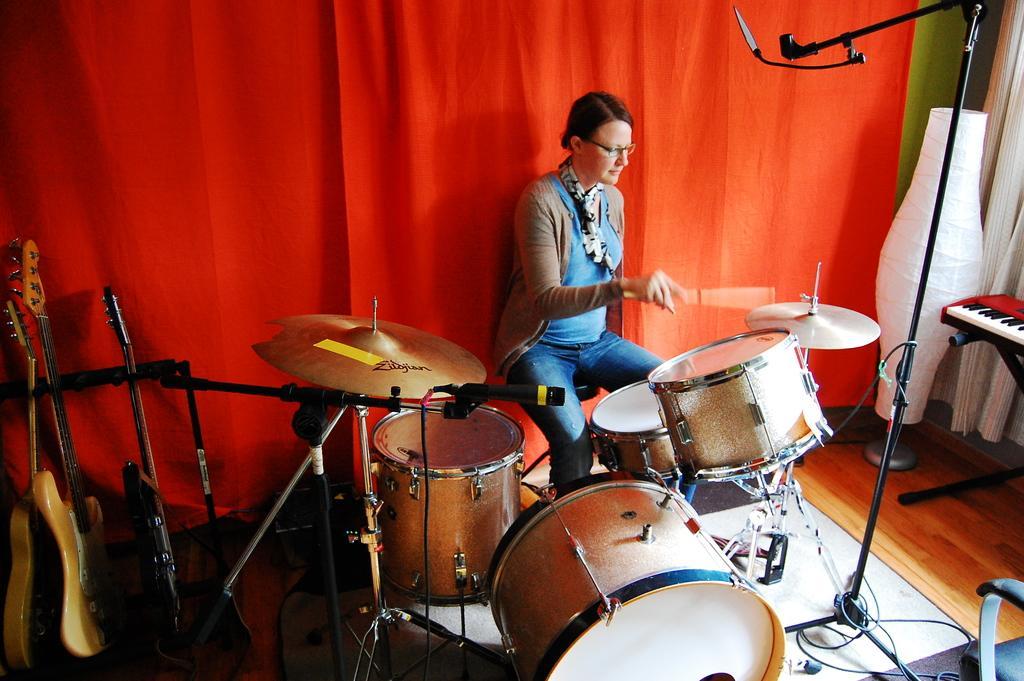Describe this image in one or two sentences. He is sitting on a chair. He is wearing a spectacle and scarf. He is playing a musical drums. We can see in background red color curtain,stand and Musical drums. 